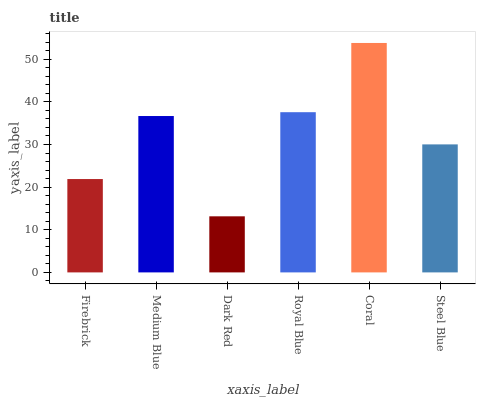Is Dark Red the minimum?
Answer yes or no. Yes. Is Coral the maximum?
Answer yes or no. Yes. Is Medium Blue the minimum?
Answer yes or no. No. Is Medium Blue the maximum?
Answer yes or no. No. Is Medium Blue greater than Firebrick?
Answer yes or no. Yes. Is Firebrick less than Medium Blue?
Answer yes or no. Yes. Is Firebrick greater than Medium Blue?
Answer yes or no. No. Is Medium Blue less than Firebrick?
Answer yes or no. No. Is Medium Blue the high median?
Answer yes or no. Yes. Is Steel Blue the low median?
Answer yes or no. Yes. Is Dark Red the high median?
Answer yes or no. No. Is Medium Blue the low median?
Answer yes or no. No. 